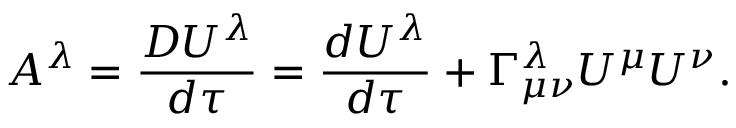Convert formula to latex. <formula><loc_0><loc_0><loc_500><loc_500>A ^ { \lambda } = \frac { D U ^ { \lambda } } { d \tau } = \frac { d U ^ { \lambda } } { d \tau } + \Gamma _ { \mu \nu } ^ { \lambda } U ^ { \mu } U ^ { \nu } .</formula> 